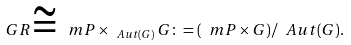<formula> <loc_0><loc_0><loc_500><loc_500>\ G R \cong \ m P \times _ { \ A u t ( G ) } G \colon = ( \ m P \times G ) / \ A u t ( G ) .</formula> 